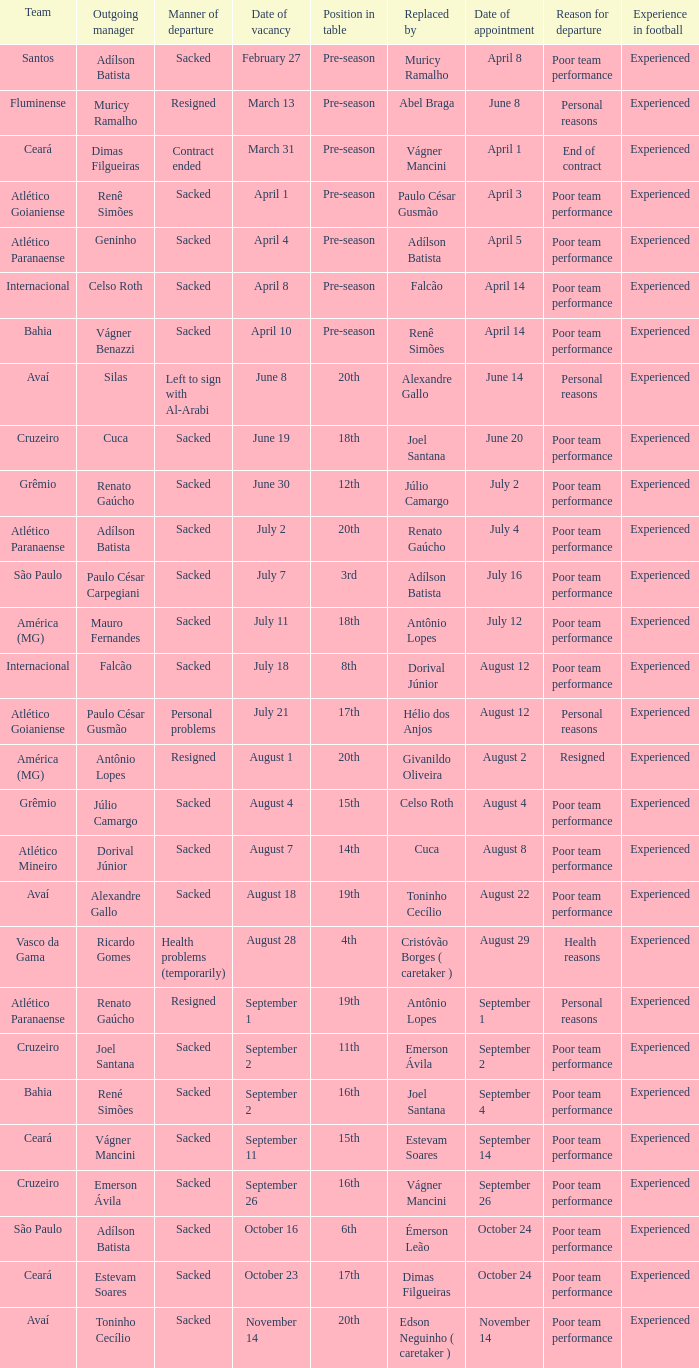How many times did Silas leave as a team manager? 1.0. 